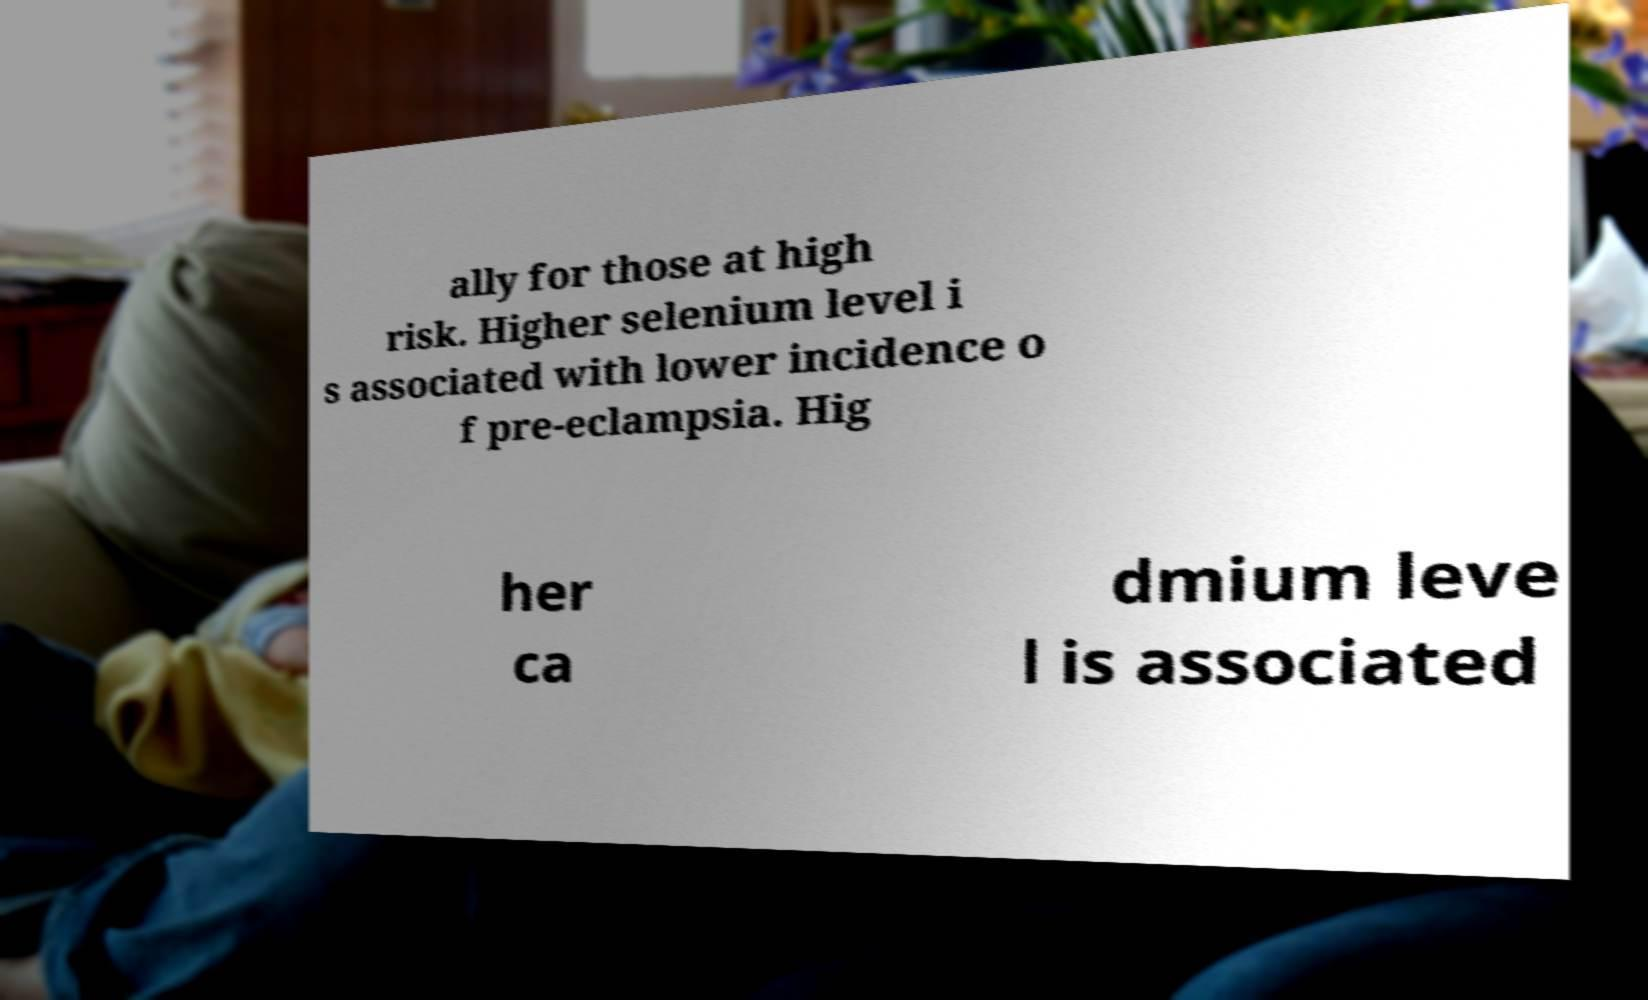Please identify and transcribe the text found in this image. ally for those at high risk. Higher selenium level i s associated with lower incidence o f pre-eclampsia. Hig her ca dmium leve l is associated 